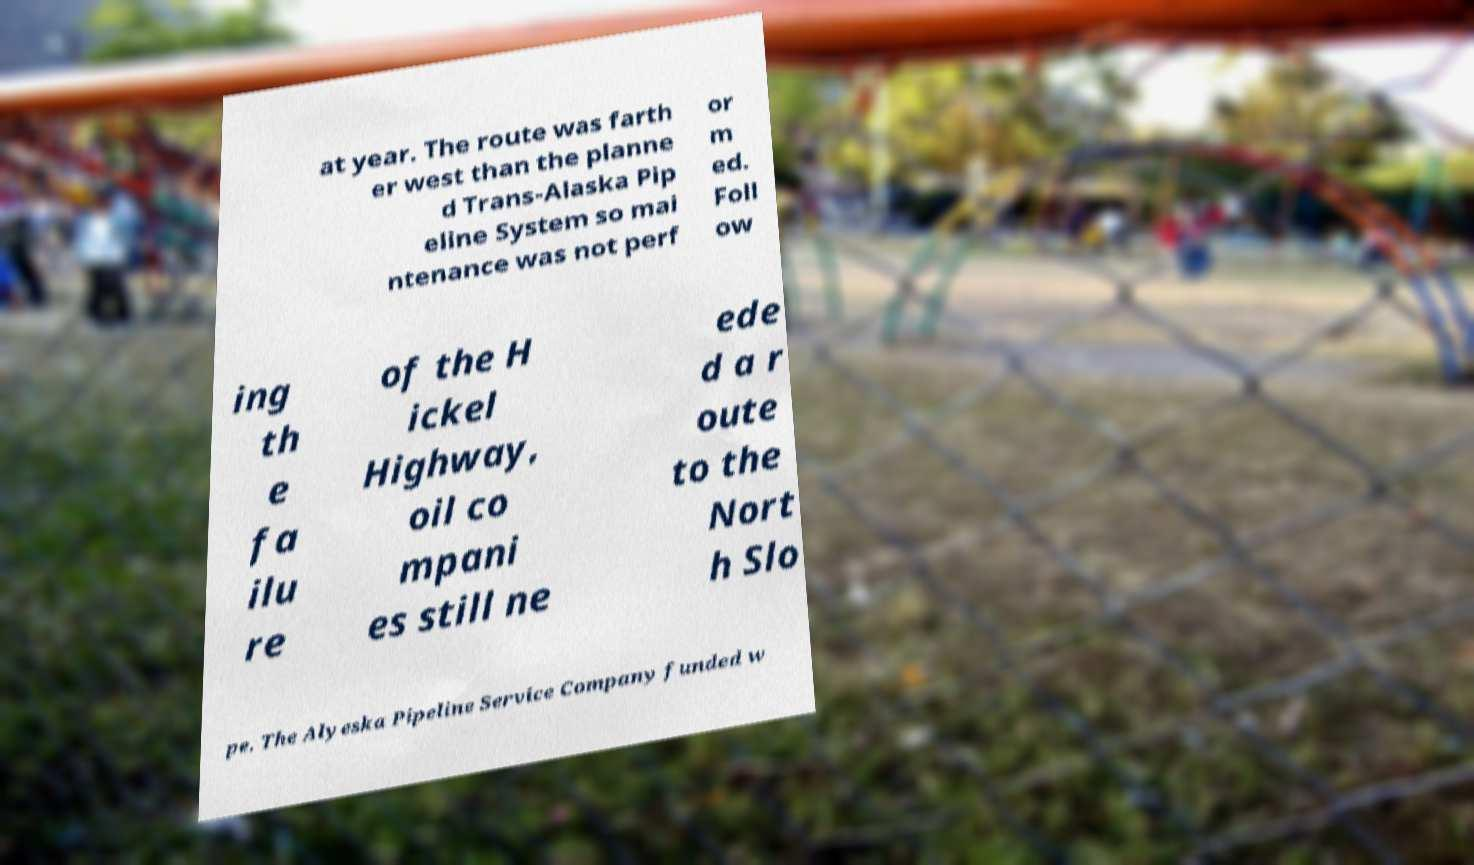Can you accurately transcribe the text from the provided image for me? at year. The route was farth er west than the planne d Trans-Alaska Pip eline System so mai ntenance was not perf or m ed. Foll ow ing th e fa ilu re of the H ickel Highway, oil co mpani es still ne ede d a r oute to the Nort h Slo pe. The Alyeska Pipeline Service Company funded w 